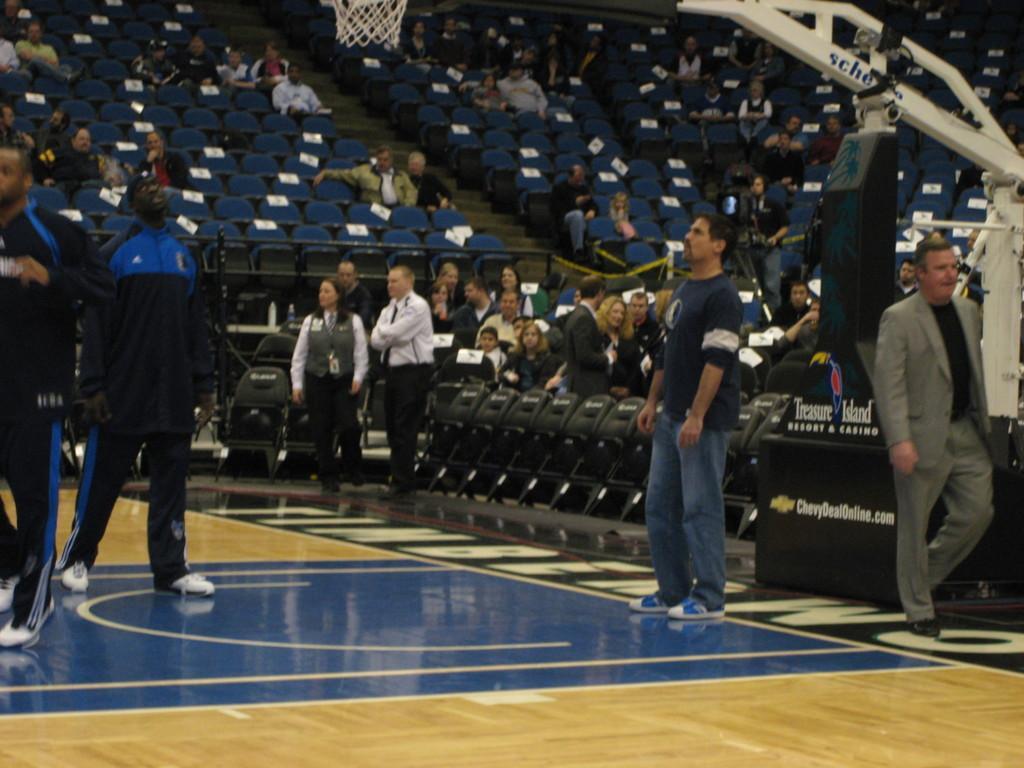Please provide a concise description of this image. This image is clicked in the stadium. There are chairs in this image. People are sitting on chairs. In the middle some people are standing. There is a basketball net at the top. 